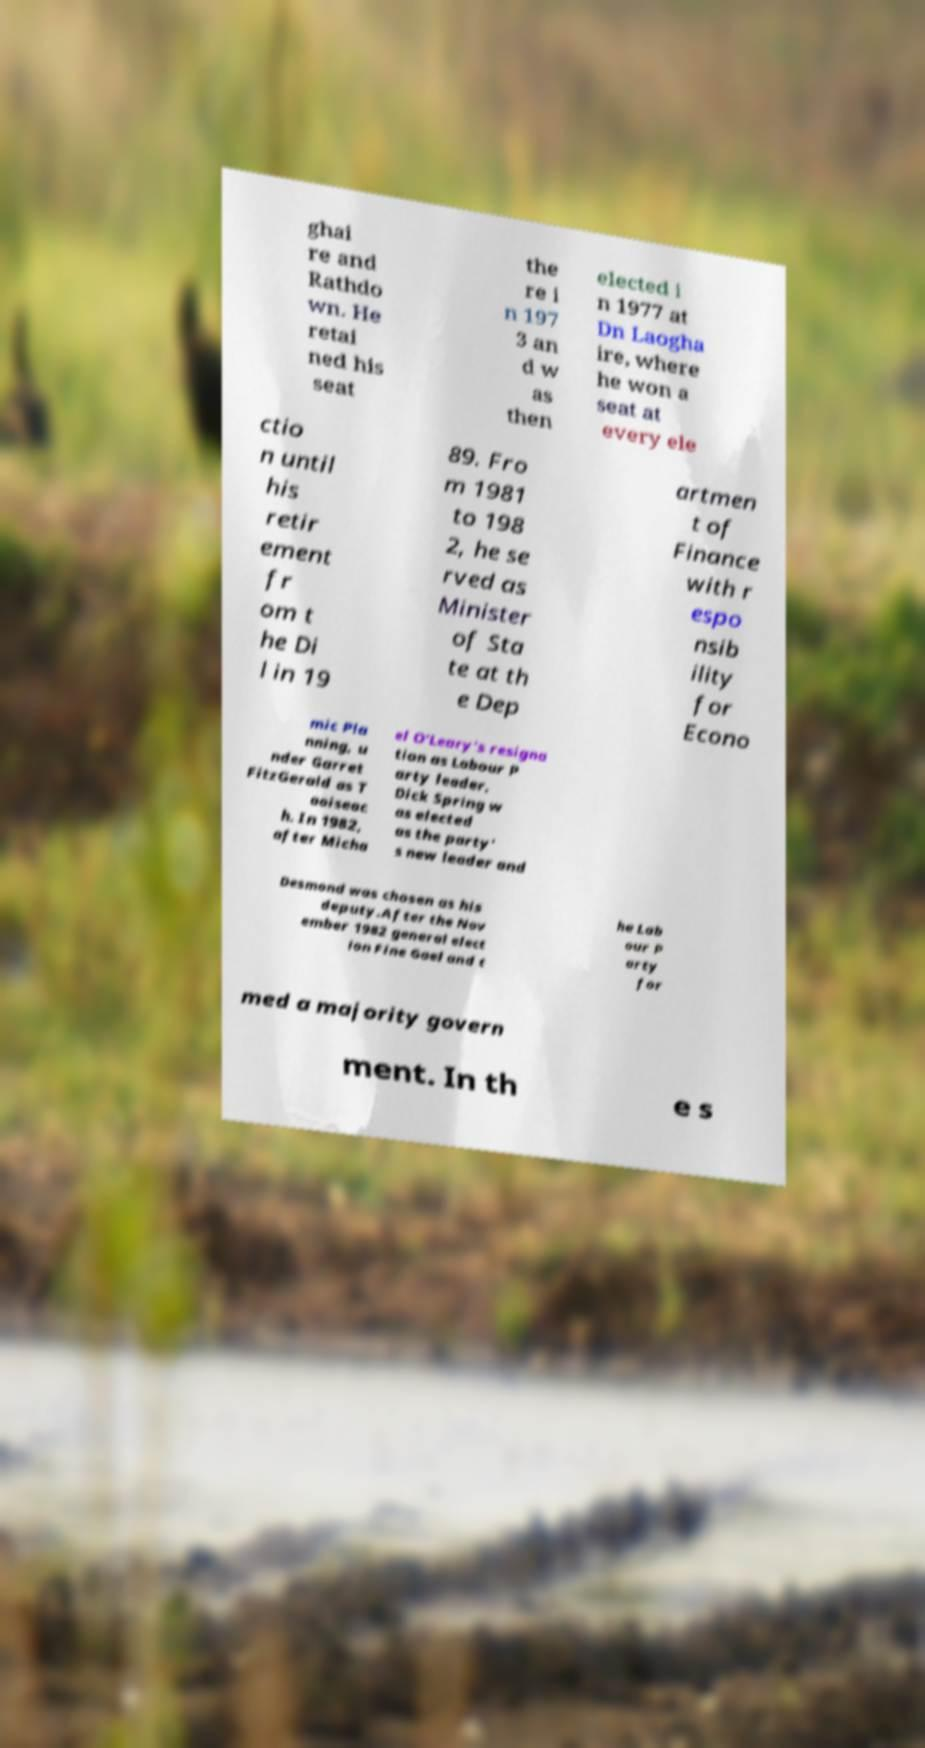Can you read and provide the text displayed in the image?This photo seems to have some interesting text. Can you extract and type it out for me? ghai re and Rathdo wn. He retai ned his seat the re i n 197 3 an d w as then elected i n 1977 at Dn Laogha ire, where he won a seat at every ele ctio n until his retir ement fr om t he Di l in 19 89. Fro m 1981 to 198 2, he se rved as Minister of Sta te at th e Dep artmen t of Finance with r espo nsib ility for Econo mic Pla nning, u nder Garret FitzGerald as T aoiseac h. In 1982, after Micha el O'Leary's resigna tion as Labour P arty leader, Dick Spring w as elected as the party' s new leader and Desmond was chosen as his deputy.After the Nov ember 1982 general elect ion Fine Gael and t he Lab our P arty for med a majority govern ment. In th e s 